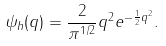<formula> <loc_0><loc_0><loc_500><loc_500>\psi _ { h } ( q ) = \frac { 2 } { \pi ^ { 1 / 2 } } q ^ { 2 } e ^ { - \frac { 1 } { 2 } q ^ { 2 } } .</formula> 